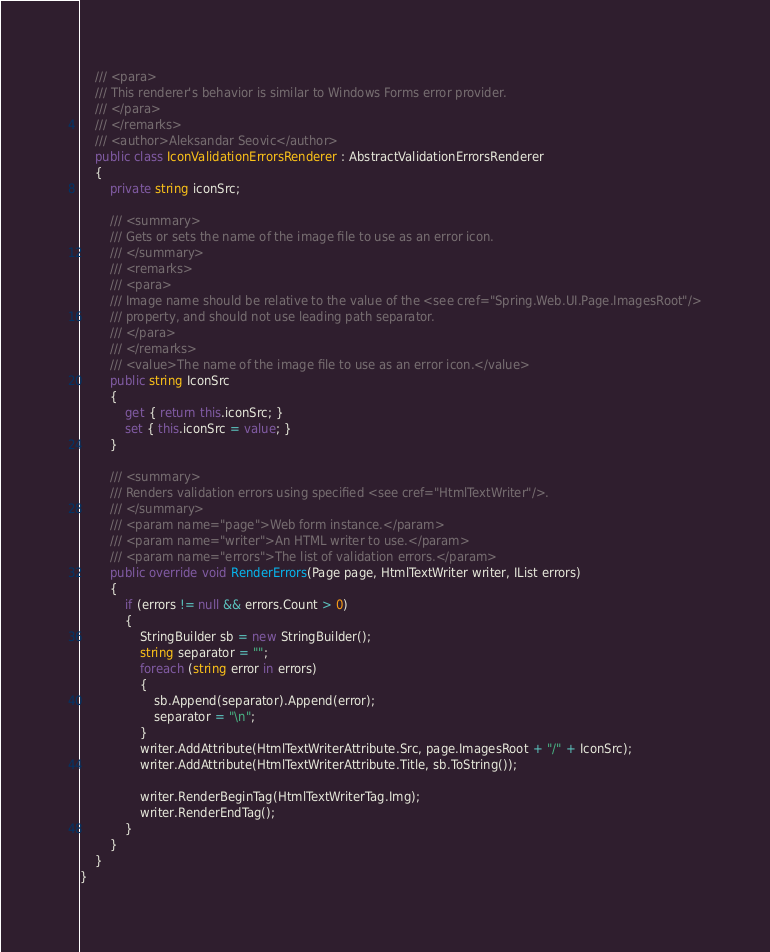Convert code to text. <code><loc_0><loc_0><loc_500><loc_500><_C#_>    /// <para>
    /// This renderer's behavior is similar to Windows Forms error provider.
    /// </para>
    /// </remarks>
    /// <author>Aleksandar Seovic</author>
    public class IconValidationErrorsRenderer : AbstractValidationErrorsRenderer
    {
        private string iconSrc;

        /// <summary>
        /// Gets or sets the name of the image file to use as an error icon.
        /// </summary>
        /// <remarks>
        /// <para>
        /// Image name should be relative to the value of the <see cref="Spring.Web.UI.Page.ImagesRoot"/>
        /// property, and should not use leading path separator.
        /// </para>
        /// </remarks>
        /// <value>The name of the image file to use as an error icon.</value>
        public string IconSrc
        {
            get { return this.iconSrc; }
            set { this.iconSrc = value; }
        }

        /// <summary>
        /// Renders validation errors using specified <see cref="HtmlTextWriter"/>.
        /// </summary>
        /// <param name="page">Web form instance.</param>
        /// <param name="writer">An HTML writer to use.</param>
        /// <param name="errors">The list of validation errors.</param>
        public override void RenderErrors(Page page, HtmlTextWriter writer, IList errors)
        {
            if (errors != null && errors.Count > 0)
            {
                StringBuilder sb = new StringBuilder();
                string separator = "";
                foreach (string error in errors)
                {
                    sb.Append(separator).Append(error);
                    separator = "\n";
                }
                writer.AddAttribute(HtmlTextWriterAttribute.Src, page.ImagesRoot + "/" + IconSrc);
                writer.AddAttribute(HtmlTextWriterAttribute.Title, sb.ToString());

                writer.RenderBeginTag(HtmlTextWriterTag.Img);                
                writer.RenderEndTag();
            }
        }
    }
}</code> 